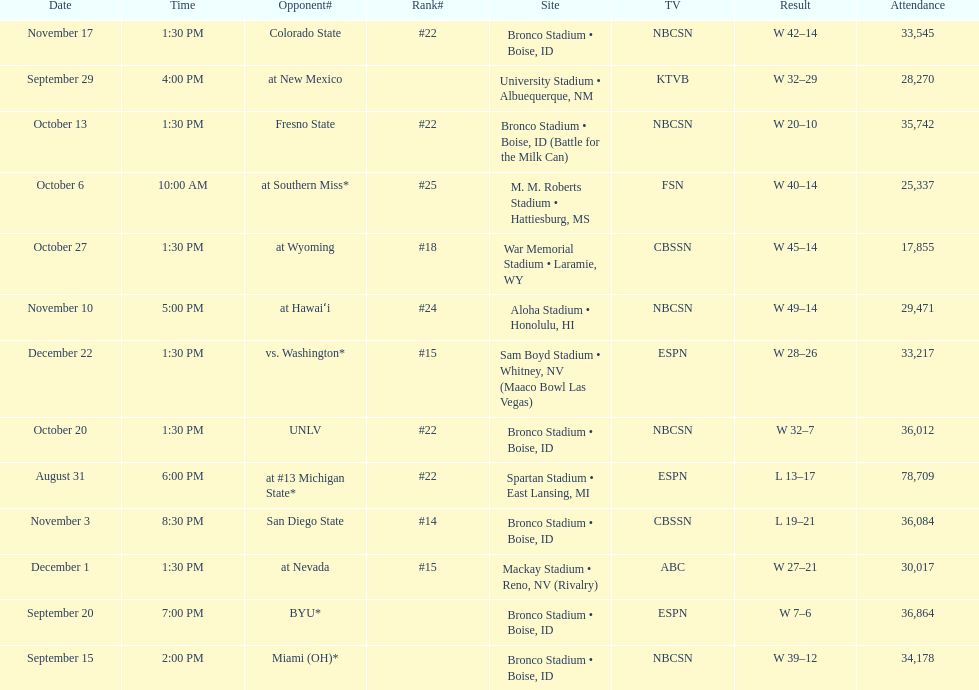Number of points scored by miami (oh) against the broncos. 12. 